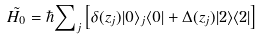<formula> <loc_0><loc_0><loc_500><loc_500>\tilde { H _ { 0 } } = \hbar { \sum } _ { j } \left [ \delta ( z _ { j } ) | 0 \rangle _ { j } \langle 0 | + \Delta ( z _ { j } ) | 2 \rangle \langle 2 | \right ]</formula> 